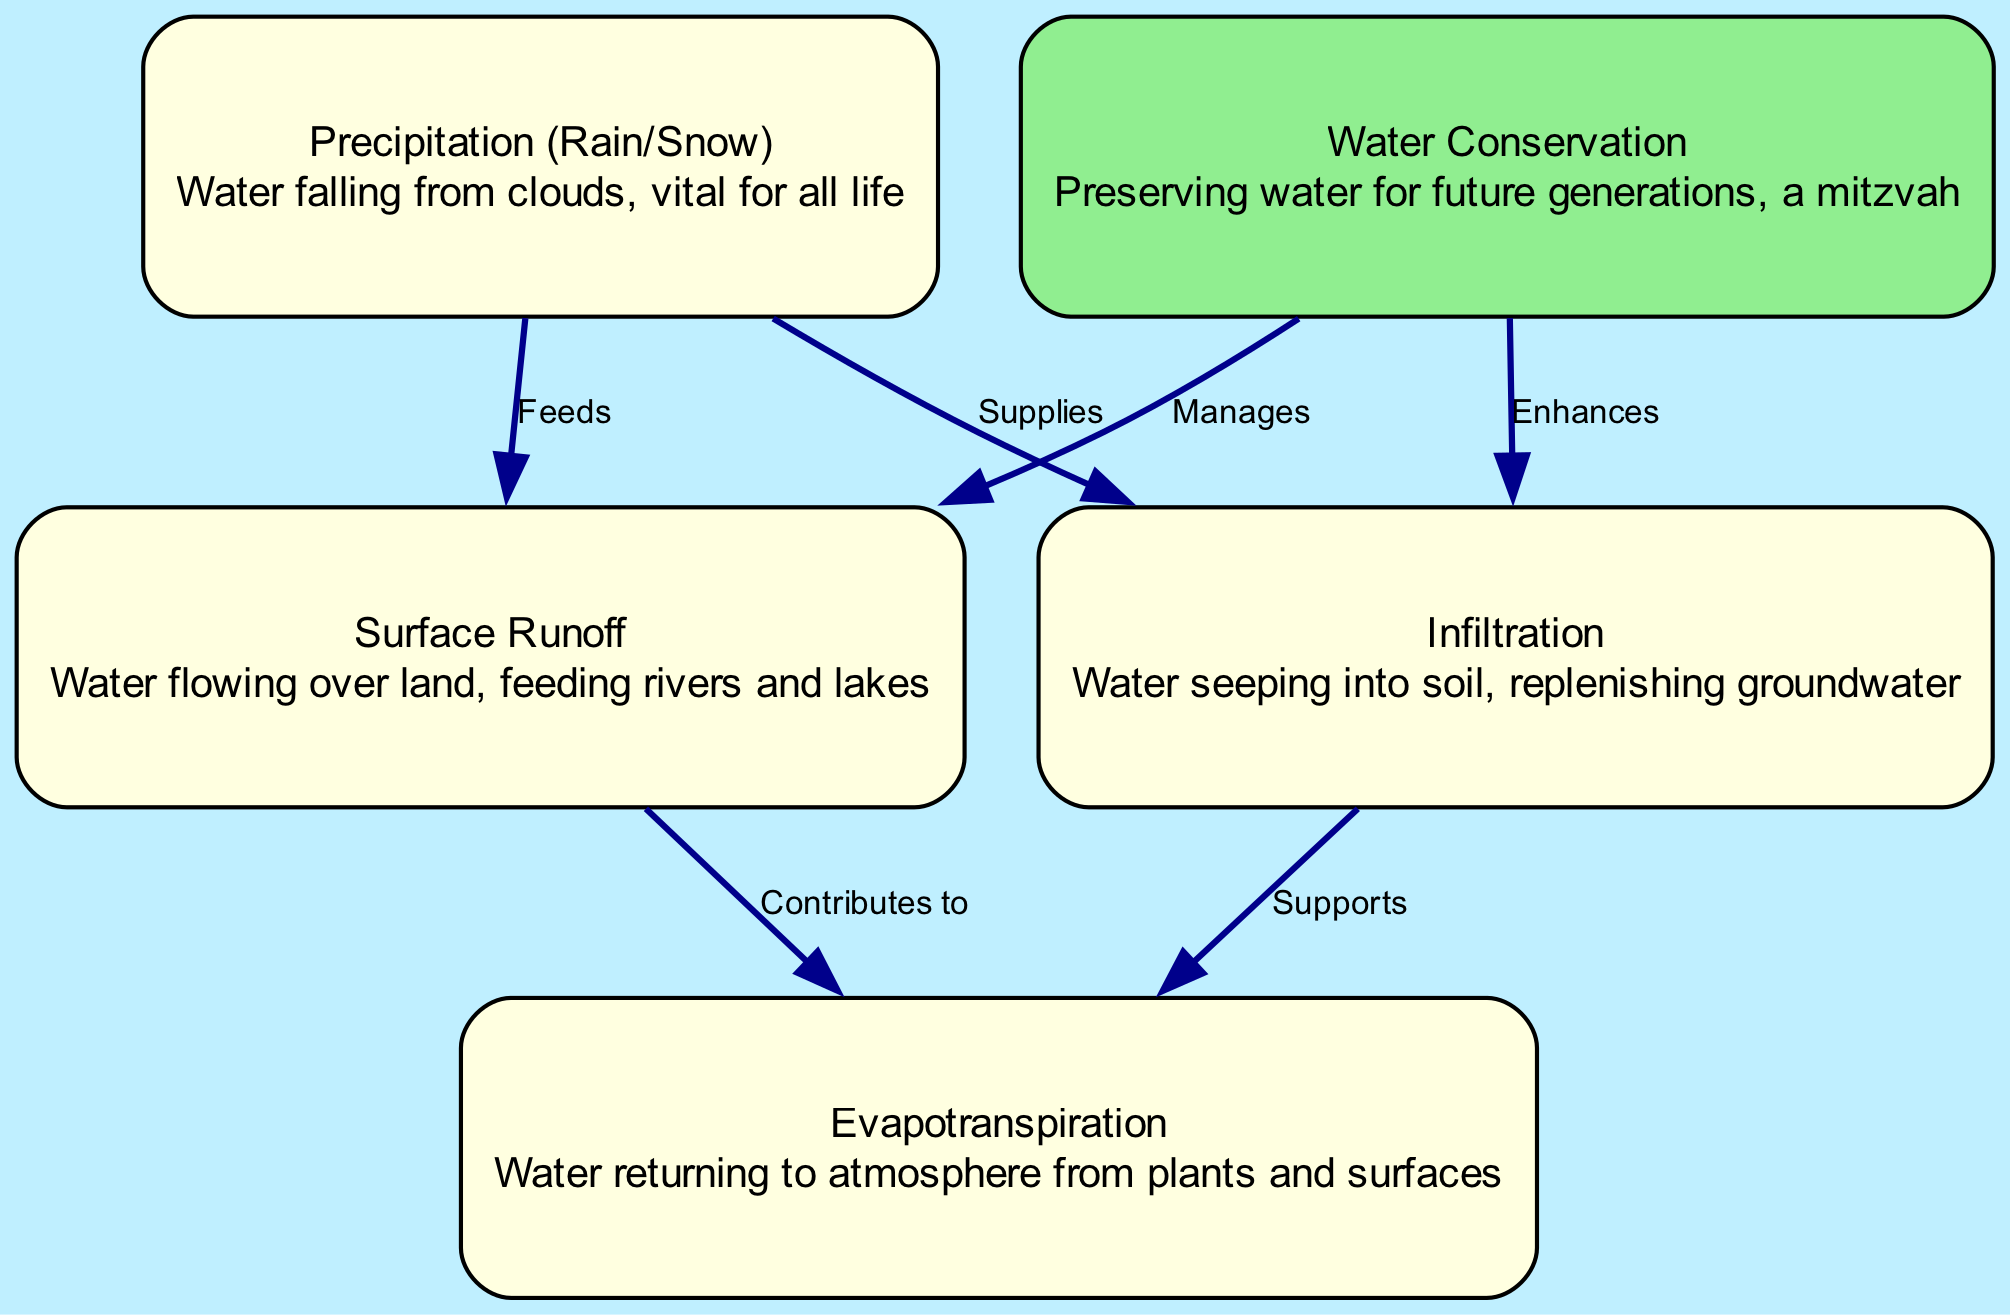What are the components of the water cycle represented in the diagram? The diagram includes five components: precipitation, surface runoff, infiltration, evapotranspiration, and conservation. These are clearly labeled as nodes in the diagram.
Answer: precipitation, surface runoff, infiltration, evapotranspiration, conservation How does precipitation affect surface runoff? According to the diagram, precipitation "feeds" surface runoff, indicating a direct relationship where water from precipitation contributes to the flow of water over land.
Answer: Feeds How many edges are present in the diagram? The diagram shows a total of six edges connecting various nodes, depicting the relationships between components of the water cycle.
Answer: 6 What role does conservation play in relation to infiltration? The diagram states that conservation "enhances" infiltration, indicating that efforts to conserve water improve the process of water seeping into the soil.
Answer: Enhances Which process supports evapotranspiration besides surface runoff? The diagram indicates that infiltration also "supports" evapotranspiration, illustrating the interconnectedness of these processes in the water cycle.
Answer: Supports What type of node is highlighted in the diagram? The conservation node is highlighted, marked with a different color (light green) to emphasize its importance in managing water and its relevance to the water cycle.
Answer: Conservation What is a vital resource provided by precipitation? The diagram indicates that precipitation provides water, a crucial resource for all life forms, as noted in its description.
Answer: Water How does surface runoff contribute to other processes in the water cycle? Surface runoff contributes to evapotranspiration, as indicated in the diagram, showing how water flowing over land is integrated into atmospheric processes.
Answer: Contributes to 